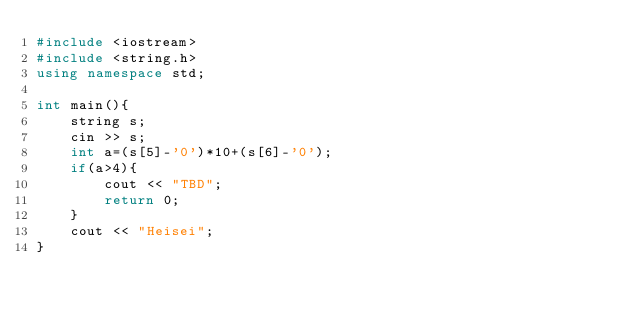Convert code to text. <code><loc_0><loc_0><loc_500><loc_500><_C++_>#include <iostream>
#include <string.h>
using namespace std;

int main(){
    string s;
    cin >> s;
    int a=(s[5]-'0')*10+(s[6]-'0');
    if(a>4){
        cout << "TBD";
        return 0;
    }
    cout << "Heisei";
}</code> 